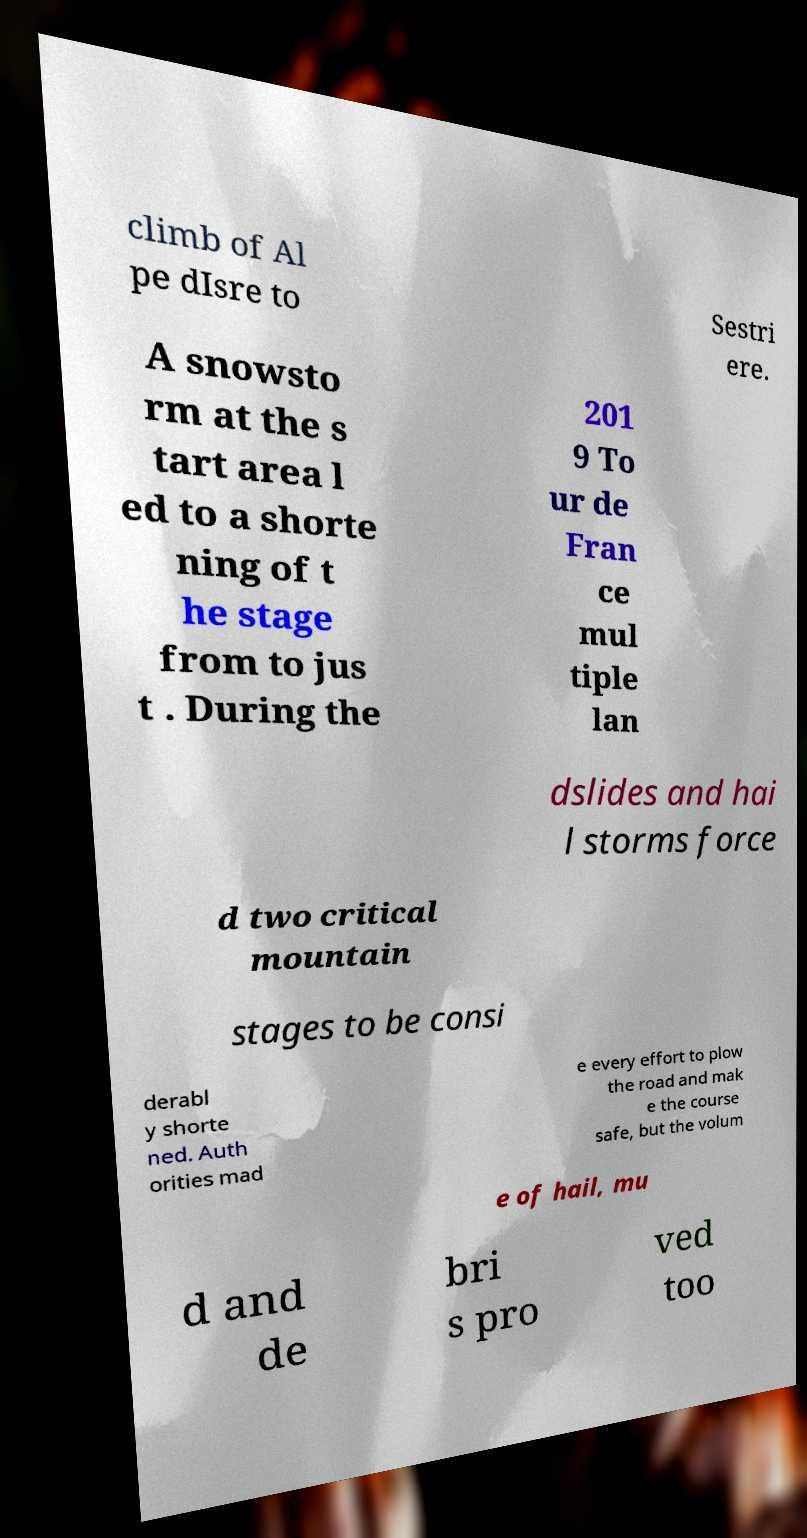I need the written content from this picture converted into text. Can you do that? climb of Al pe dIsre to Sestri ere. A snowsto rm at the s tart area l ed to a shorte ning of t he stage from to jus t . During the 201 9 To ur de Fran ce mul tiple lan dslides and hai l storms force d two critical mountain stages to be consi derabl y shorte ned. Auth orities mad e every effort to plow the road and mak e the course safe, but the volum e of hail, mu d and de bri s pro ved too 